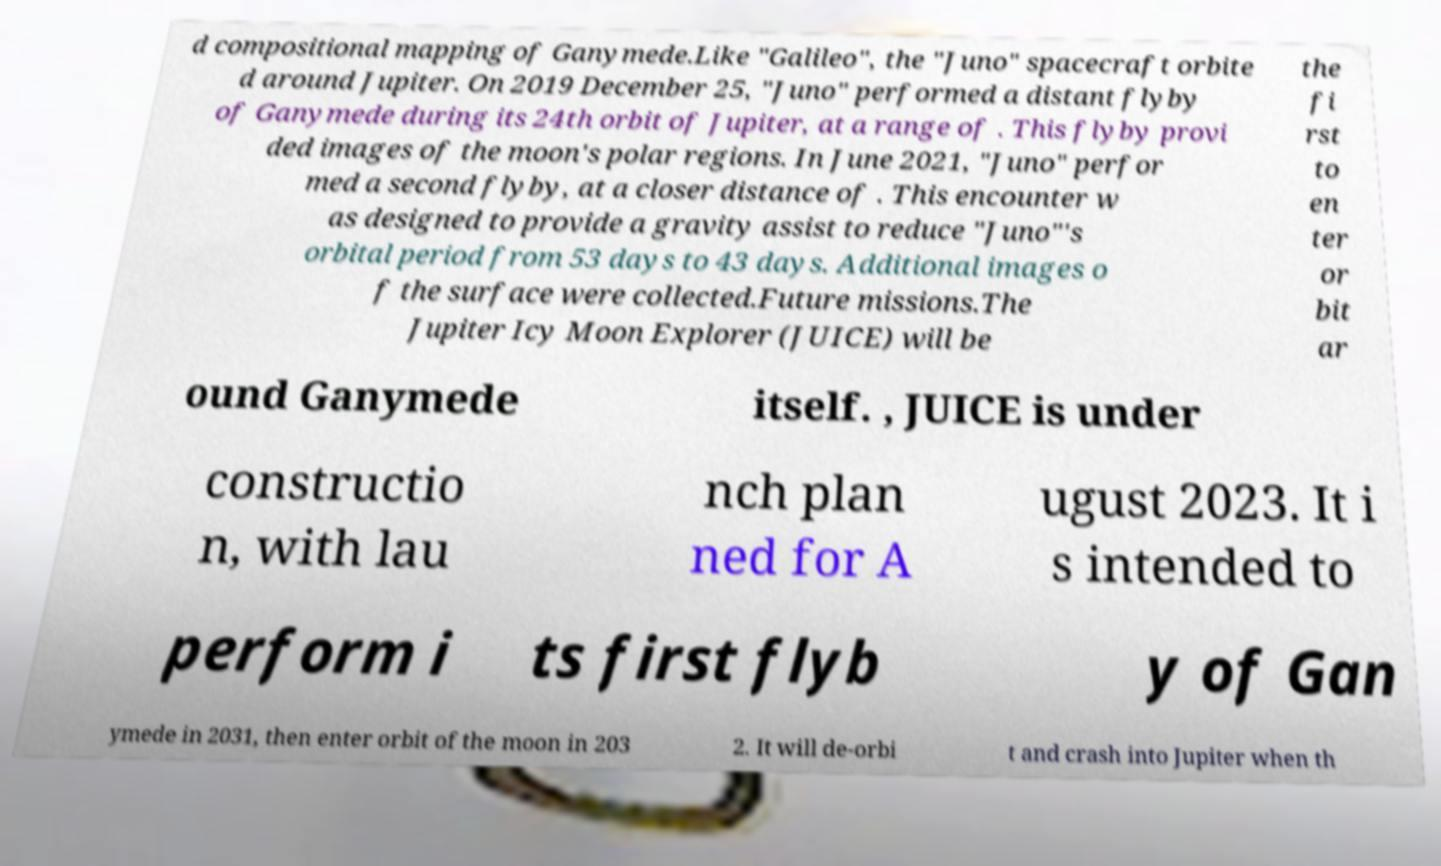Could you assist in decoding the text presented in this image and type it out clearly? d compositional mapping of Ganymede.Like "Galileo", the "Juno" spacecraft orbite d around Jupiter. On 2019 December 25, "Juno" performed a distant flyby of Ganymede during its 24th orbit of Jupiter, at a range of . This flyby provi ded images of the moon's polar regions. In June 2021, "Juno" perfor med a second flyby, at a closer distance of . This encounter w as designed to provide a gravity assist to reduce "Juno"'s orbital period from 53 days to 43 days. Additional images o f the surface were collected.Future missions.The Jupiter Icy Moon Explorer (JUICE) will be the fi rst to en ter or bit ar ound Ganymede itself. , JUICE is under constructio n, with lau nch plan ned for A ugust 2023. It i s intended to perform i ts first flyb y of Gan ymede in 2031, then enter orbit of the moon in 203 2. It will de-orbi t and crash into Jupiter when th 